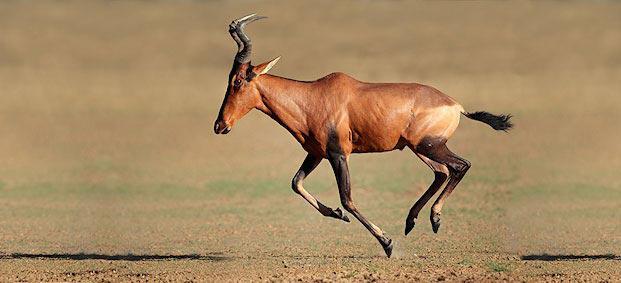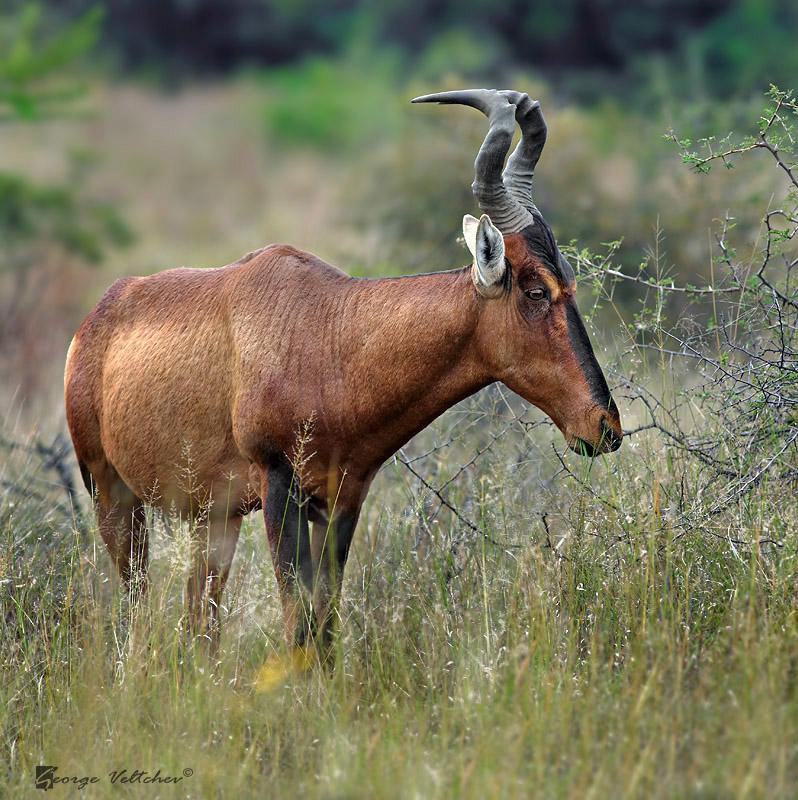The first image is the image on the left, the second image is the image on the right. Evaluate the accuracy of this statement regarding the images: "In one of the images there is a hunter posing behind an animal.". Is it true? Answer yes or no. No. 